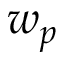<formula> <loc_0><loc_0><loc_500><loc_500>w _ { p }</formula> 